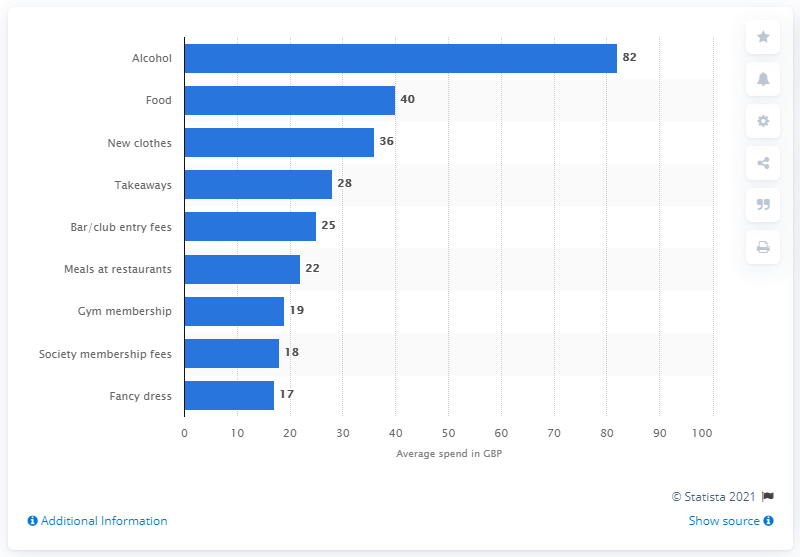Highlight a few significant elements in this photo. In the UK, during Freshers' week, students on average spent 82 pounds on alcohol. During Freshers' week, students spent an estimated 40 pounds on food. 